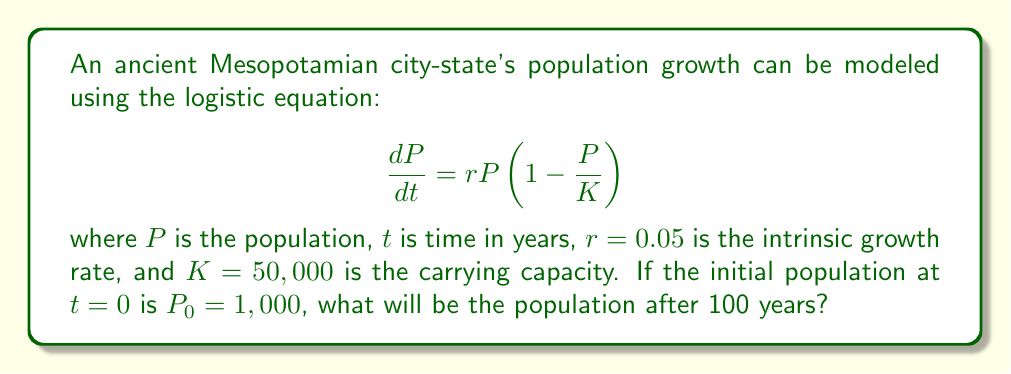Solve this math problem. To solve this problem, we need to follow these steps:

1. The general solution to the logistic equation is:

   $$P(t) = \frac{K}{1 + (\frac{K}{P_0} - 1)e^{-rt}}$$

2. We are given:
   $K = 50,000$
   $P_0 = 1,000$
   $r = 0.05$
   $t = 100$

3. Let's substitute these values into the equation:

   $$P(100) = \frac{50,000}{1 + (\frac{50,000}{1,000} - 1)e^{-0.05(100)}}$$

4. Simplify the fraction inside the parentheses:

   $$P(100) = \frac{50,000}{1 + (49)e^{-5}}$$

5. Calculate $e^{-5}$:

   $$P(100) = \frac{50,000}{1 + 49(0.00674)}$$

6. Multiply inside the parentheses:

   $$P(100) = \frac{50,000}{1 + 0.33026}$$

7. Add in the denominator:

   $$P(100) = \frac{50,000}{1.33026}$$

8. Divide:

   $$P(100) = 37,586.79$$

9. Round to the nearest whole number, as we're dealing with a population:

   $$P(100) \approx 37,587$$
Answer: 37,587 people 